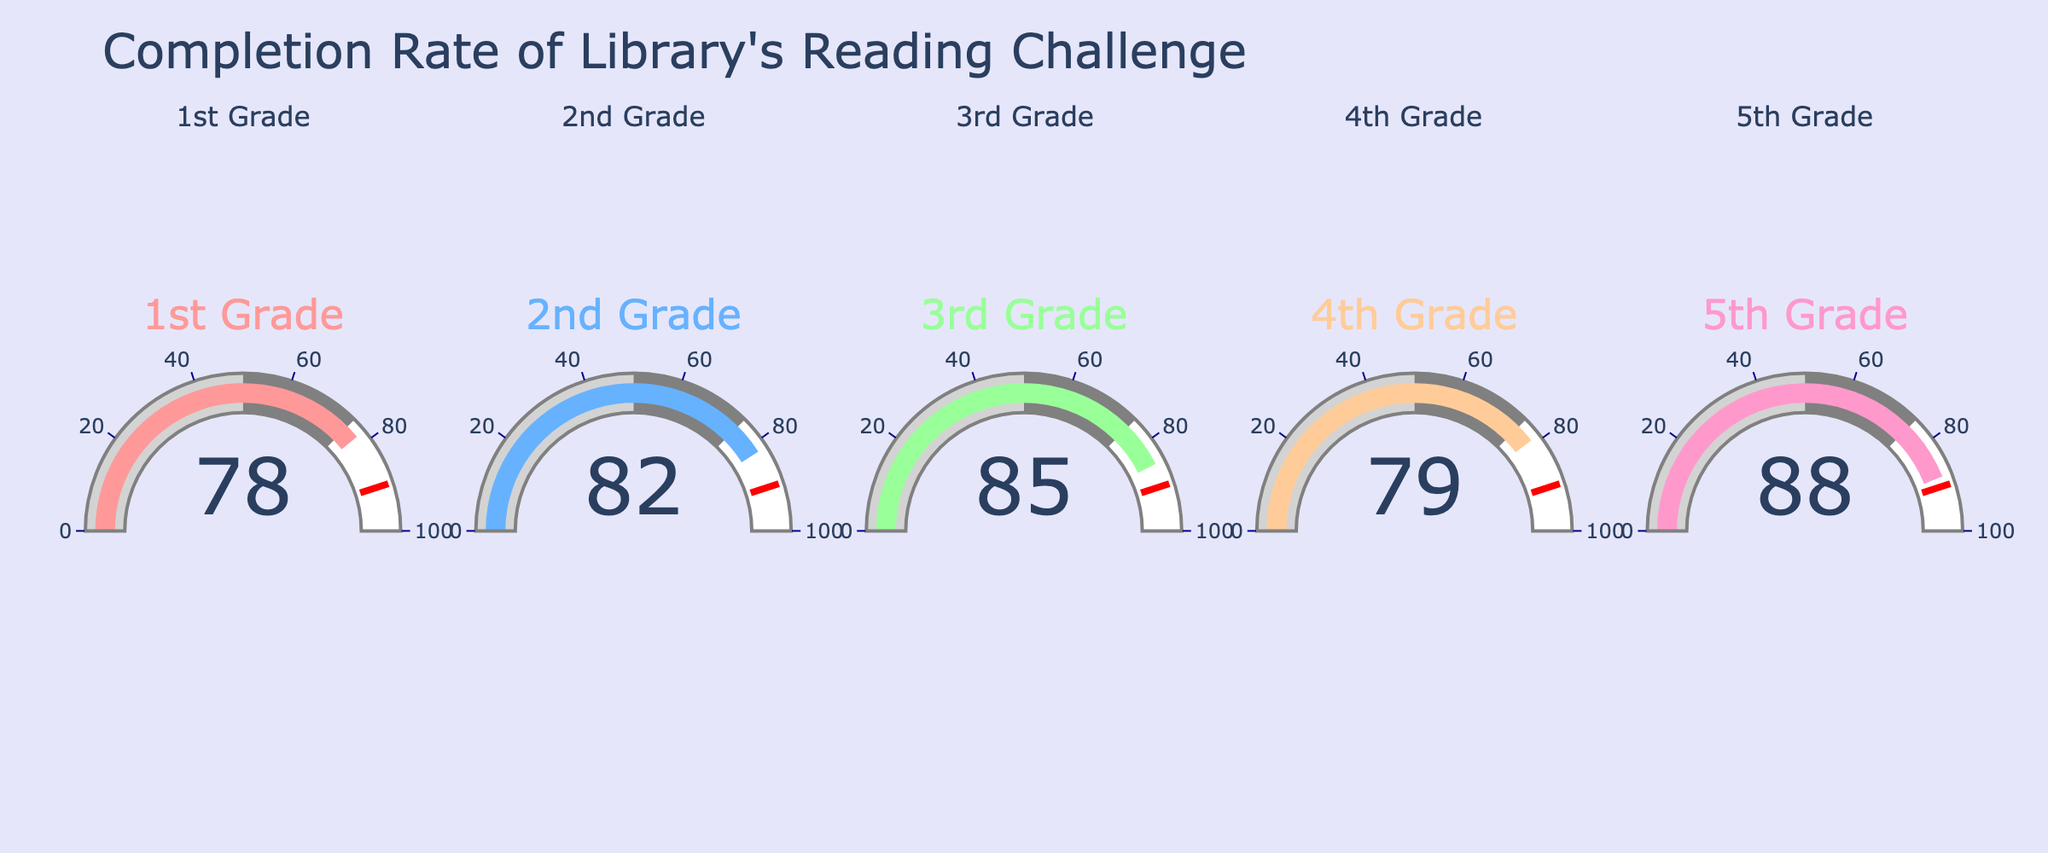What is the title of the chart? The title of the chart is typically displayed at the top of the figure, which is used to give a summary of what the chart represents. In this case, the title is "Completion Rate of Library's Reading Challenge".
Answer: Completion Rate of Library's Reading Challenge Which grade has the highest completion rate? By examining the gauge values displayed in the figure, the grade with the highest percentage will be identified. For this chart, the highest value is 88.
Answer: 5th Grade Which grade has the lowest completion rate? Similarly, to find the lowest completion rate, we look for the gauge with the smallest value among the gauges. The gauge with the smallest value is 78.
Answer: 1st Grade How many grades have completion rates above 80%? We count the number of gauges that show a value greater than 80. This includes values of 82, 85, and 88.
Answer: 3 grades What is the average completion rate across all grades? To find the average, sum all the completion rates: 78 + 82 + 85 + 79 + 88 = 412. Then, divide by the number of grades, which is 5. The average is 412 / 5.
Answer: 82.4 Which grade has a completion rate closest to 80%? We look for the gauge whose value is nearest to 80. The closest values are 79 from the 4th Grade and 82 from the 2nd Grade. The absolute difference with 80 is smallest for 79.
Answer: 4th Grade Is the completion rate for any grade above the threshold value of 90%? A visual check on the gauges will show that none of the values reach or surpass the threshold of 90%. The highest value present is 88%.
Answer: No What is the range of completion rates across all grades? To calculate the range, subtract the smallest value from the largest value: 88 (5th Grade) - 78 (1st Grade). This gives the span of completion rates.
Answer: 10 Compare the completion rates of 1st Grade and 4th Grade. Which is higher? By comparing the values visually, we see that 1st Grade has a completion rate of 78%, and 4th Grade has a completion rate of 79%.
Answer: 4th Grade 